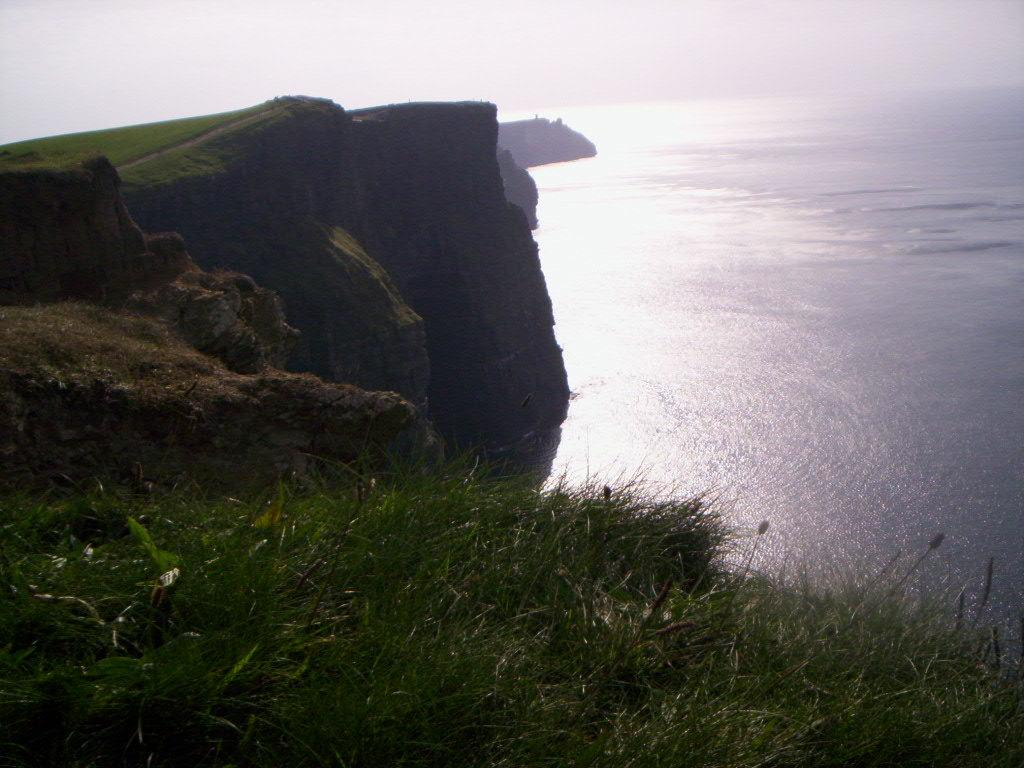What type of terrain is visible in the image? There are hills in the image. What type of vegetation is present in the image? There is grass and plants visible in the image. What natural feature can be seen in the image? There is water visible in the image. What part of the natural environment is visible in the image? The sky is visible in the image. What type of account can be seen in the image? There is no account visible in the image; it features natural elements such as hills, grass, plants, water, and the sky. What type of cannon is present in the image? There is no cannon present in the image; it features natural elements such as hills, grass, plants, water, and the sky. 